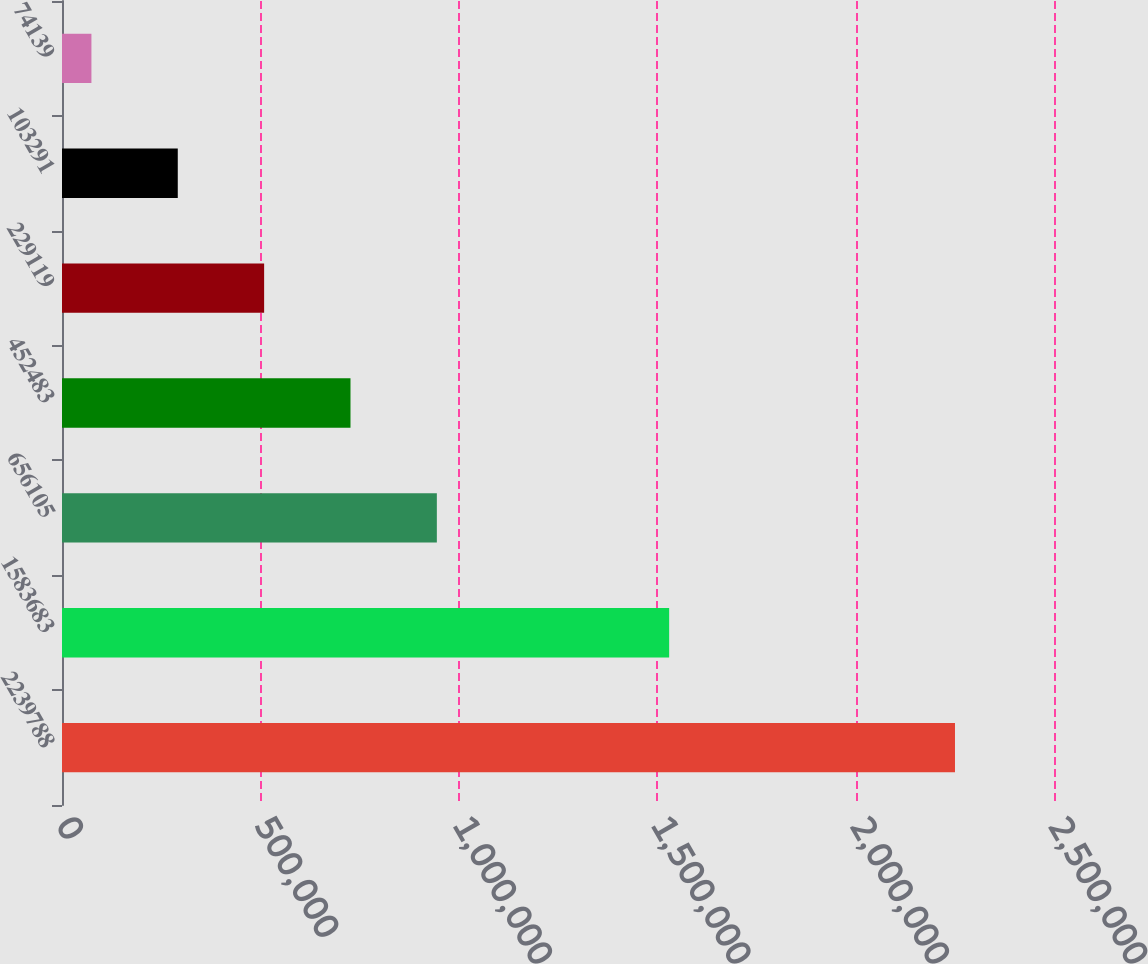<chart> <loc_0><loc_0><loc_500><loc_500><bar_chart><fcel>2239788<fcel>1583683<fcel>656105<fcel>452483<fcel>229119<fcel>103291<fcel>74139<nl><fcel>2.25047e+06<fcel>1.53012e+06<fcel>944673<fcel>727039<fcel>509406<fcel>291772<fcel>74139<nl></chart> 